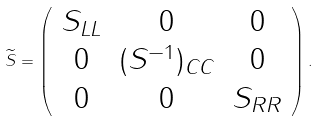Convert formula to latex. <formula><loc_0><loc_0><loc_500><loc_500>\widetilde { S } = \left ( \begin{array} { c c c } S _ { L L } & 0 & 0 \\ 0 & ( S ^ { - 1 } ) _ { C C } & 0 \\ 0 & 0 & S _ { R R } \\ \end{array} \right ) .</formula> 